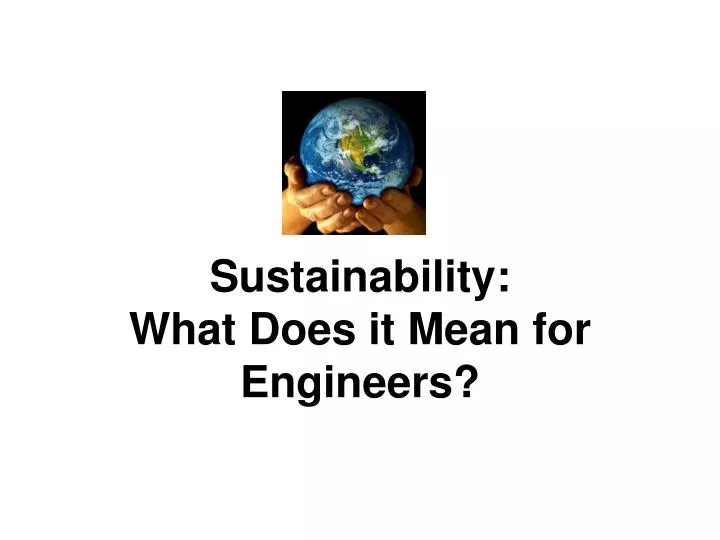If this image inspired a children's story about engineering and the environment, what would be a creative plot? Title: 'Ella and the Eco-Engineers'
In a bustling city, young Ella discovers a secret society of Eco-Engineers who are dedicated to saving the planet. Guided by Professor Greenleaf, the society’s leader, Ella and her new friends embark on magical adventures, solving environmental challenges using engineering principles. They build a solar-powered treehouse, create a river-cleaning robot, and design wind turbines to power the city. Along the way, they learn valuable lessons about teamwork, innovation, and the importance of caring for the Earth. Their greatest adventure comes when they must stop an imminent threat to their city caused by pollution, proving that even the smallest hands can make a big difference when everyone works together. 